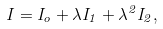Convert formula to latex. <formula><loc_0><loc_0><loc_500><loc_500>I = I _ { o } + \lambda I _ { 1 } + \lambda ^ { 2 } I _ { 2 } ,</formula> 